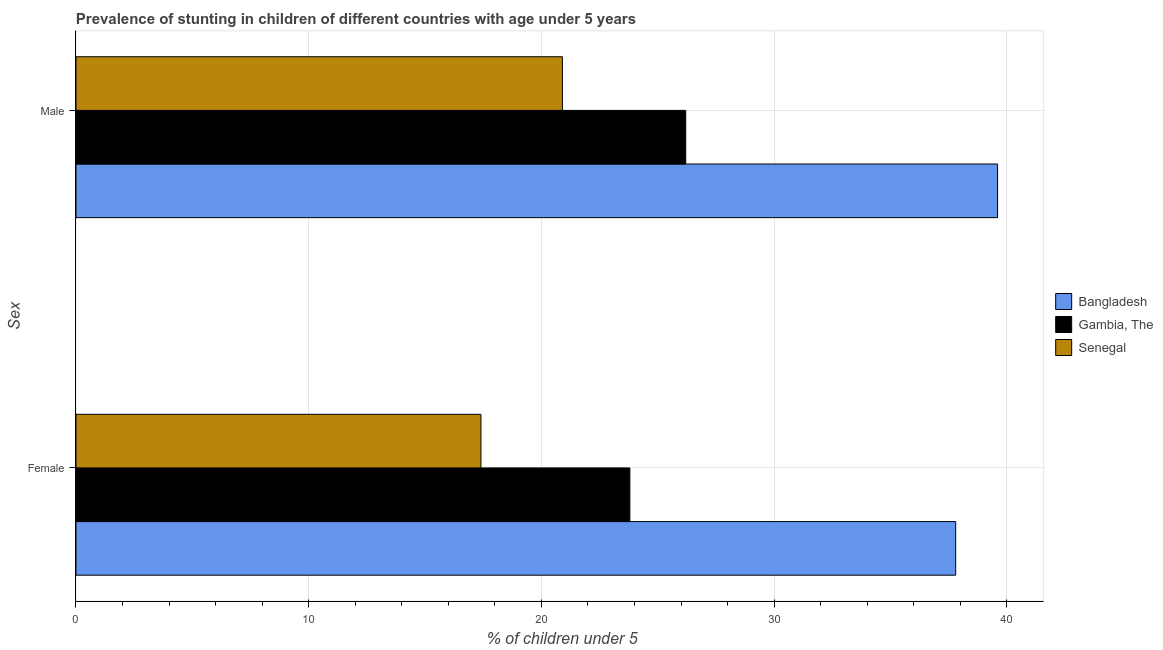How many groups of bars are there?
Provide a succinct answer. 2. How many bars are there on the 2nd tick from the top?
Your answer should be compact. 3. What is the label of the 1st group of bars from the top?
Give a very brief answer. Male. What is the percentage of stunted female children in Bangladesh?
Keep it short and to the point. 37.8. Across all countries, what is the maximum percentage of stunted male children?
Ensure brevity in your answer.  39.6. Across all countries, what is the minimum percentage of stunted female children?
Offer a terse response. 17.4. In which country was the percentage of stunted female children minimum?
Your answer should be compact. Senegal. What is the total percentage of stunted female children in the graph?
Give a very brief answer. 79. What is the difference between the percentage of stunted male children in Bangladesh and that in Senegal?
Provide a succinct answer. 18.7. What is the difference between the percentage of stunted female children in Bangladesh and the percentage of stunted male children in Senegal?
Provide a short and direct response. 16.9. What is the average percentage of stunted male children per country?
Your answer should be very brief. 28.9. What is the difference between the percentage of stunted female children and percentage of stunted male children in Gambia, The?
Make the answer very short. -2.4. What is the ratio of the percentage of stunted female children in Gambia, The to that in Senegal?
Your answer should be very brief. 1.37. Is the percentage of stunted male children in Bangladesh less than that in Senegal?
Offer a very short reply. No. In how many countries, is the percentage of stunted female children greater than the average percentage of stunted female children taken over all countries?
Your answer should be very brief. 1. What does the 1st bar from the top in Female represents?
Make the answer very short. Senegal. What does the 3rd bar from the bottom in Male represents?
Offer a very short reply. Senegal. How many countries are there in the graph?
Your answer should be very brief. 3. Are the values on the major ticks of X-axis written in scientific E-notation?
Offer a very short reply. No. Does the graph contain any zero values?
Ensure brevity in your answer.  No. What is the title of the graph?
Keep it short and to the point. Prevalence of stunting in children of different countries with age under 5 years. Does "French Polynesia" appear as one of the legend labels in the graph?
Give a very brief answer. No. What is the label or title of the X-axis?
Offer a very short reply.  % of children under 5. What is the label or title of the Y-axis?
Ensure brevity in your answer.  Sex. What is the  % of children under 5 in Bangladesh in Female?
Your response must be concise. 37.8. What is the  % of children under 5 in Gambia, The in Female?
Offer a terse response. 23.8. What is the  % of children under 5 in Senegal in Female?
Make the answer very short. 17.4. What is the  % of children under 5 in Bangladesh in Male?
Your answer should be very brief. 39.6. What is the  % of children under 5 of Gambia, The in Male?
Ensure brevity in your answer.  26.2. What is the  % of children under 5 of Senegal in Male?
Ensure brevity in your answer.  20.9. Across all Sex, what is the maximum  % of children under 5 of Bangladesh?
Provide a succinct answer. 39.6. Across all Sex, what is the maximum  % of children under 5 of Gambia, The?
Offer a very short reply. 26.2. Across all Sex, what is the maximum  % of children under 5 of Senegal?
Offer a very short reply. 20.9. Across all Sex, what is the minimum  % of children under 5 in Bangladesh?
Provide a short and direct response. 37.8. Across all Sex, what is the minimum  % of children under 5 in Gambia, The?
Your response must be concise. 23.8. Across all Sex, what is the minimum  % of children under 5 in Senegal?
Provide a short and direct response. 17.4. What is the total  % of children under 5 in Bangladesh in the graph?
Ensure brevity in your answer.  77.4. What is the total  % of children under 5 in Gambia, The in the graph?
Make the answer very short. 50. What is the total  % of children under 5 of Senegal in the graph?
Your response must be concise. 38.3. What is the difference between the  % of children under 5 in Bangladesh in Female and that in Male?
Offer a terse response. -1.8. What is the difference between the  % of children under 5 in Senegal in Female and that in Male?
Give a very brief answer. -3.5. What is the difference between the  % of children under 5 of Bangladesh in Female and the  % of children under 5 of Gambia, The in Male?
Give a very brief answer. 11.6. What is the difference between the  % of children under 5 of Bangladesh in Female and the  % of children under 5 of Senegal in Male?
Your response must be concise. 16.9. What is the average  % of children under 5 in Bangladesh per Sex?
Offer a very short reply. 38.7. What is the average  % of children under 5 of Senegal per Sex?
Keep it short and to the point. 19.15. What is the difference between the  % of children under 5 of Bangladesh and  % of children under 5 of Gambia, The in Female?
Give a very brief answer. 14. What is the difference between the  % of children under 5 of Bangladesh and  % of children under 5 of Senegal in Female?
Make the answer very short. 20.4. What is the difference between the  % of children under 5 in Bangladesh and  % of children under 5 in Gambia, The in Male?
Your answer should be compact. 13.4. What is the difference between the  % of children under 5 in Gambia, The and  % of children under 5 in Senegal in Male?
Make the answer very short. 5.3. What is the ratio of the  % of children under 5 of Bangladesh in Female to that in Male?
Give a very brief answer. 0.95. What is the ratio of the  % of children under 5 in Gambia, The in Female to that in Male?
Give a very brief answer. 0.91. What is the ratio of the  % of children under 5 of Senegal in Female to that in Male?
Provide a succinct answer. 0.83. What is the difference between the highest and the second highest  % of children under 5 in Bangladesh?
Your response must be concise. 1.8. What is the difference between the highest and the second highest  % of children under 5 in Gambia, The?
Your answer should be compact. 2.4. What is the difference between the highest and the second highest  % of children under 5 of Senegal?
Make the answer very short. 3.5. What is the difference between the highest and the lowest  % of children under 5 in Gambia, The?
Give a very brief answer. 2.4. 